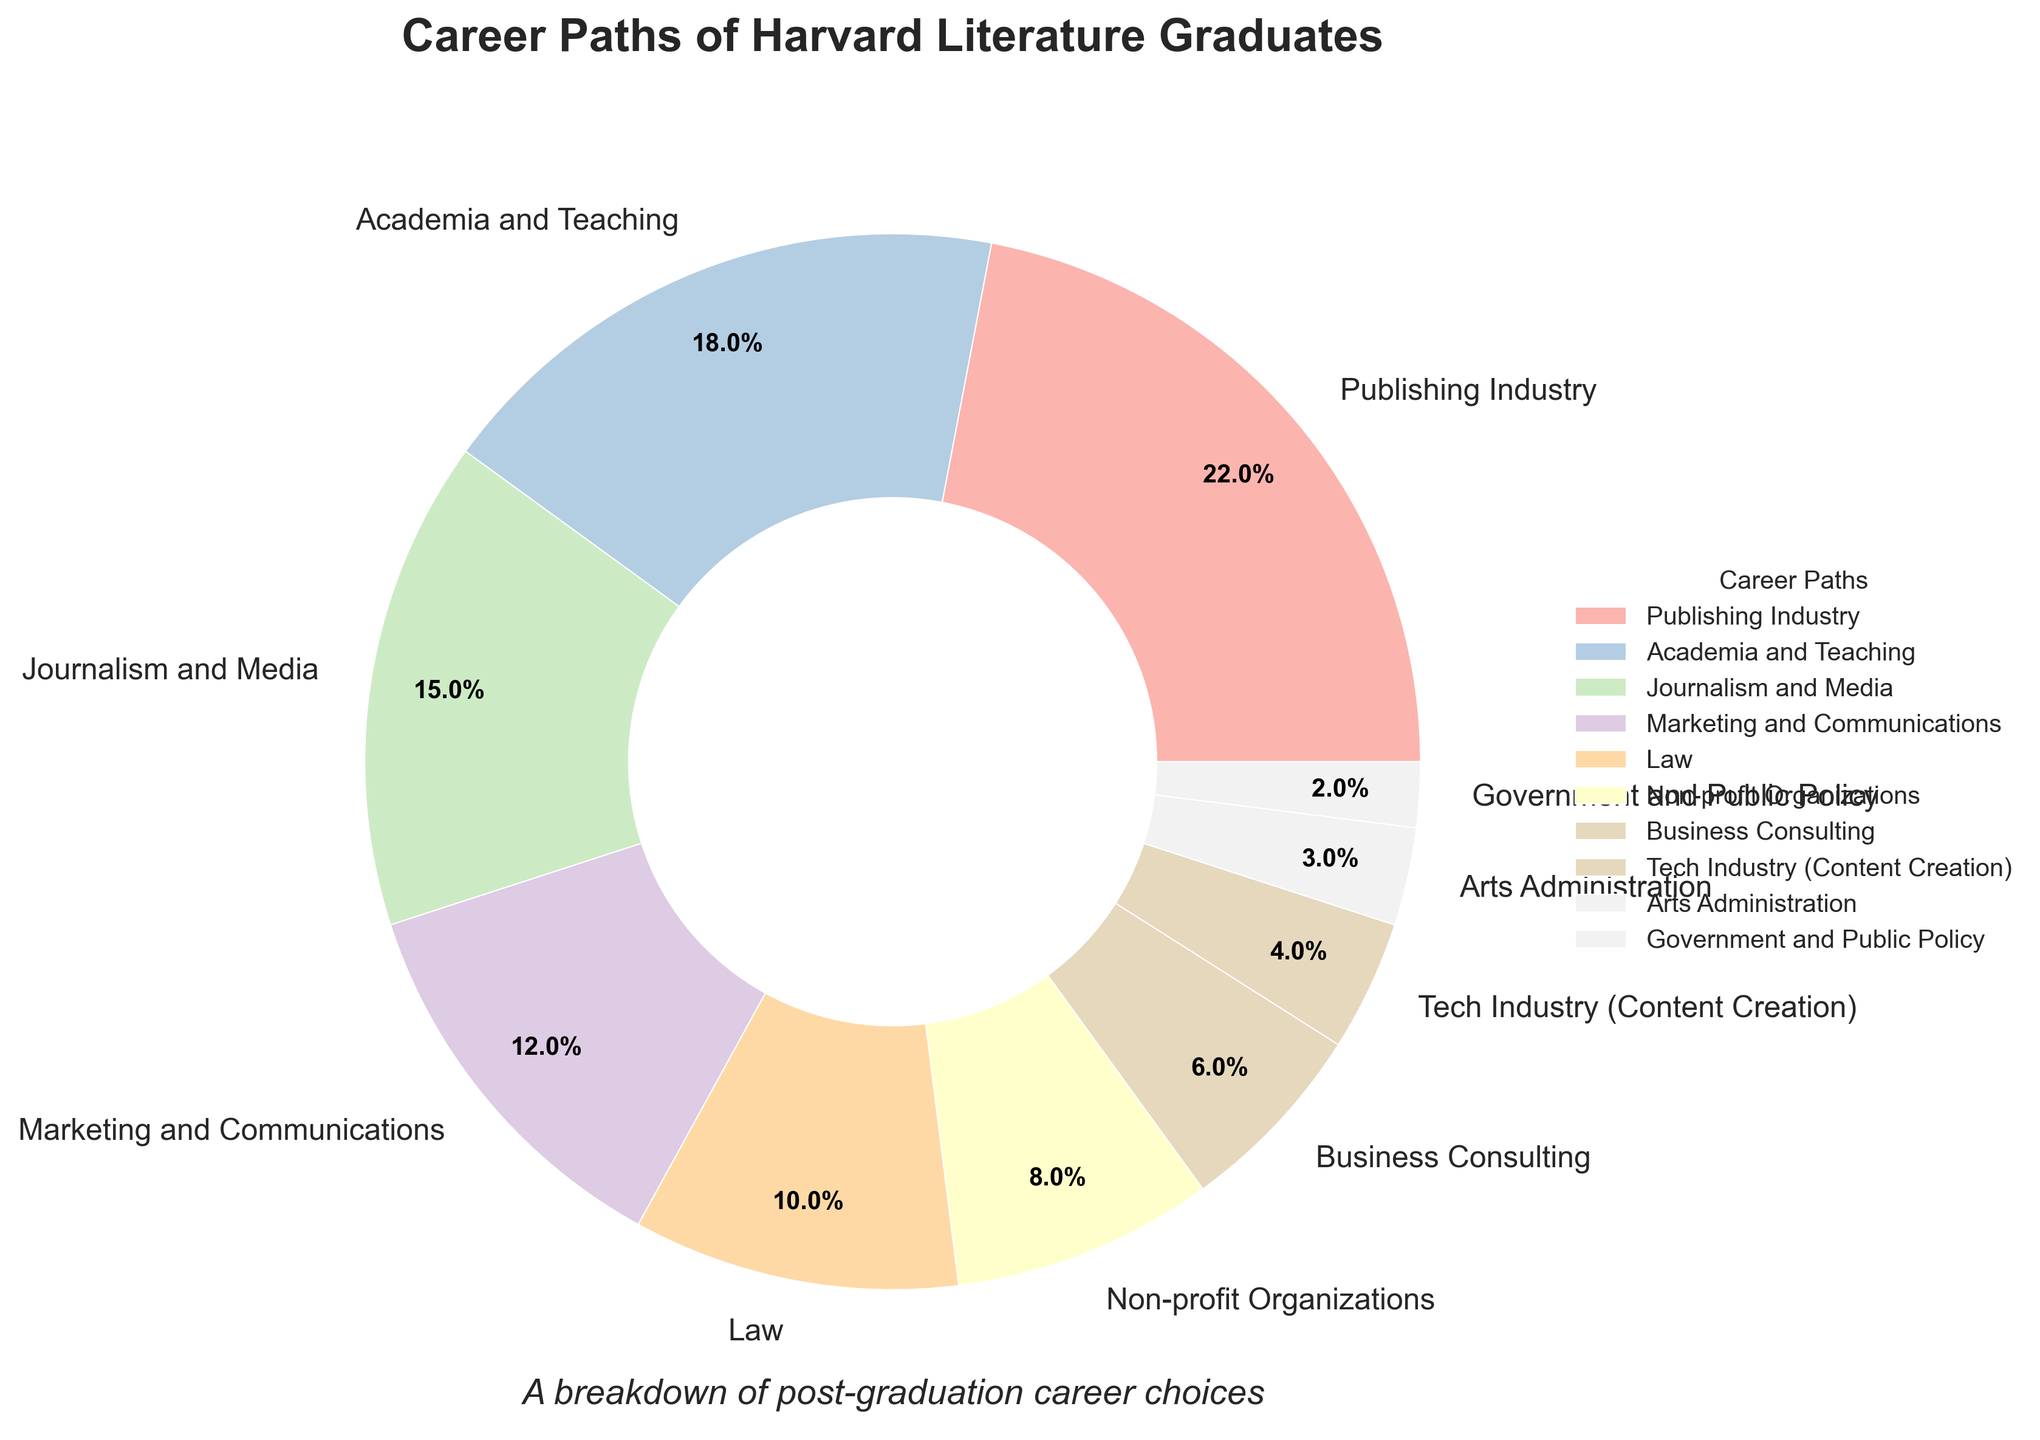What career path has the largest percentage of Harvard Literature graduates? The pie chart shows the 'Publishing Industry' has the largest wedge, indicating it has the highest percentage.
Answer: Publishing Industry Which career paths together make up more than 50% of Harvard Literature graduates? By adding the percentages from largest to smallest, Publishing Industry (22%) + Academia and Teaching (18%) + Journalism and Media (15%) exceeds 50%.
Answer: Publishing Industry, Academia and Teaching, Journalism and Media Which sector has a higher percentage, Law or Business Consulting? From comparing the pie chart wedges, the Law sector (10%) is larger than Business Consulting (6%).
Answer: Law What is the total percentage of graduates working in the Tech Industry and Arts Administration combined? Sum the percentages of Tech Industry (4%) and Arts Administration (3%). 4% + 3% = 7%.
Answer: 7% Which career path has the smallest percentage of Harvard Literature graduates? The Government and Public Policy wedge is the smallest in the pie chart, indicating it has the lowest percentage of 2%.
Answer: Government and Public Policy Is the percentage of graduates in Non-profit Organizations higher or lower than those in Marketing and Communications? Non-profit Organizations have 8% while Marketing and Communications have 12%, making Non-profit lower.
Answer: Lower What percentage of graduates are in careers that involve writing and media? Considering Publishing Industry (22%), Journalism and Media (15%), and possibly Tech Industry (Content Creation) (4%), sum these percentages: 22% + 15% + 4% = 41%.
Answer: 41% How does the percentage of graduates in Government and Public Policy compare to the percentage in Law? Government and Public Policy (2%) is significantly lower than Law (10%).
Answer: Lower What proportion of graduates work in fields not immediately related to literature (e.g., Law, Business Consulting, Tech Industry)? Calculate the sum of percentages for Law (10%), Business Consulting (6%), and Tech Industry (4%): 10% + 6% + 4% = 20%.
Answer: 20% Do Academia and Teaching together with Marketing and Communications make up more than 25%? Adding percentages for Academia and Teaching (18%) and Marketing and Communications (12%): 18% + 12% = 30%, which is more than 25%.
Answer: Yes 